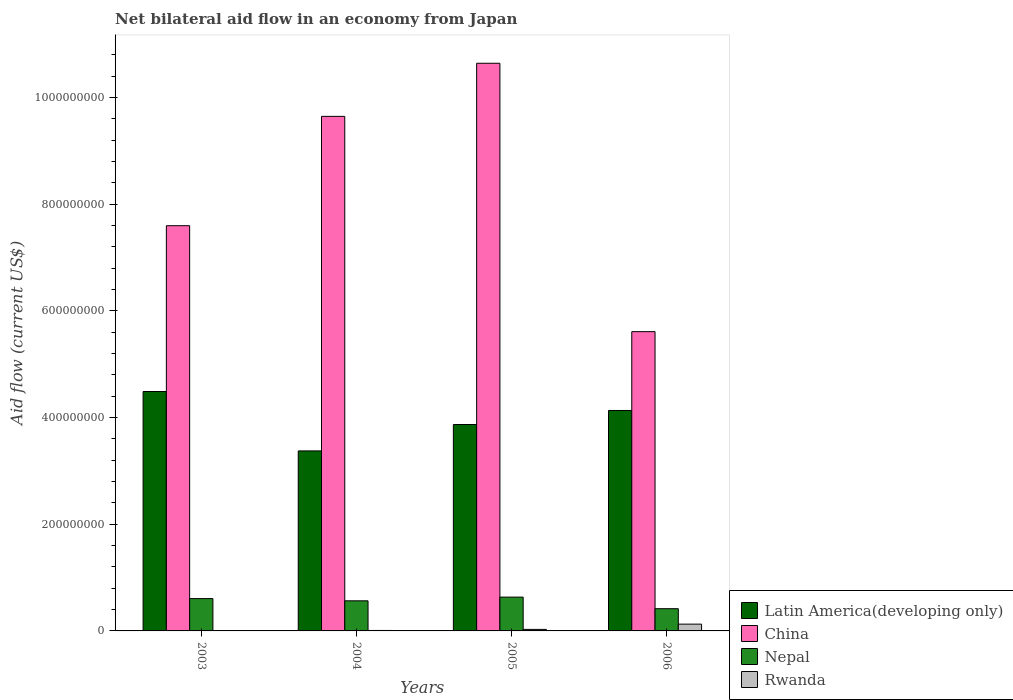How many groups of bars are there?
Your response must be concise. 4. How many bars are there on the 1st tick from the left?
Your response must be concise. 4. How many bars are there on the 2nd tick from the right?
Your answer should be very brief. 4. What is the net bilateral aid flow in Rwanda in 2003?
Make the answer very short. 6.60e+05. Across all years, what is the maximum net bilateral aid flow in Rwanda?
Your answer should be compact. 1.27e+07. Across all years, what is the minimum net bilateral aid flow in China?
Your answer should be compact. 5.61e+08. In which year was the net bilateral aid flow in Rwanda maximum?
Make the answer very short. 2006. What is the total net bilateral aid flow in Rwanda in the graph?
Provide a short and direct response. 1.71e+07. What is the difference between the net bilateral aid flow in Rwanda in 2003 and that in 2004?
Your answer should be compact. -2.00e+05. What is the difference between the net bilateral aid flow in Rwanda in 2003 and the net bilateral aid flow in China in 2004?
Offer a terse response. -9.64e+08. What is the average net bilateral aid flow in Rwanda per year?
Offer a terse response. 4.28e+06. In the year 2003, what is the difference between the net bilateral aid flow in Rwanda and net bilateral aid flow in China?
Ensure brevity in your answer.  -7.59e+08. What is the ratio of the net bilateral aid flow in Nepal in 2003 to that in 2005?
Ensure brevity in your answer.  0.96. What is the difference between the highest and the second highest net bilateral aid flow in Rwanda?
Make the answer very short. 9.89e+06. What is the difference between the highest and the lowest net bilateral aid flow in Latin America(developing only)?
Give a very brief answer. 1.11e+08. What does the 1st bar from the left in 2005 represents?
Provide a succinct answer. Latin America(developing only). Is it the case that in every year, the sum of the net bilateral aid flow in Latin America(developing only) and net bilateral aid flow in Rwanda is greater than the net bilateral aid flow in Nepal?
Offer a very short reply. Yes. How many bars are there?
Provide a short and direct response. 16. What is the difference between two consecutive major ticks on the Y-axis?
Your answer should be compact. 2.00e+08. Are the values on the major ticks of Y-axis written in scientific E-notation?
Offer a very short reply. No. Where does the legend appear in the graph?
Offer a very short reply. Bottom right. How are the legend labels stacked?
Ensure brevity in your answer.  Vertical. What is the title of the graph?
Give a very brief answer. Net bilateral aid flow in an economy from Japan. What is the label or title of the Y-axis?
Give a very brief answer. Aid flow (current US$). What is the Aid flow (current US$) in Latin America(developing only) in 2003?
Offer a terse response. 4.49e+08. What is the Aid flow (current US$) in China in 2003?
Ensure brevity in your answer.  7.60e+08. What is the Aid flow (current US$) in Nepal in 2003?
Ensure brevity in your answer.  6.06e+07. What is the Aid flow (current US$) of Latin America(developing only) in 2004?
Your answer should be compact. 3.37e+08. What is the Aid flow (current US$) in China in 2004?
Keep it short and to the point. 9.65e+08. What is the Aid flow (current US$) in Nepal in 2004?
Provide a short and direct response. 5.64e+07. What is the Aid flow (current US$) in Rwanda in 2004?
Offer a very short reply. 8.60e+05. What is the Aid flow (current US$) of Latin America(developing only) in 2005?
Give a very brief answer. 3.87e+08. What is the Aid flow (current US$) in China in 2005?
Offer a terse response. 1.06e+09. What is the Aid flow (current US$) of Nepal in 2005?
Provide a succinct answer. 6.34e+07. What is the Aid flow (current US$) of Rwanda in 2005?
Offer a terse response. 2.85e+06. What is the Aid flow (current US$) in Latin America(developing only) in 2006?
Offer a very short reply. 4.13e+08. What is the Aid flow (current US$) of China in 2006?
Offer a very short reply. 5.61e+08. What is the Aid flow (current US$) in Nepal in 2006?
Provide a short and direct response. 4.17e+07. What is the Aid flow (current US$) of Rwanda in 2006?
Your answer should be very brief. 1.27e+07. Across all years, what is the maximum Aid flow (current US$) in Latin America(developing only)?
Your answer should be very brief. 4.49e+08. Across all years, what is the maximum Aid flow (current US$) of China?
Provide a succinct answer. 1.06e+09. Across all years, what is the maximum Aid flow (current US$) of Nepal?
Provide a short and direct response. 6.34e+07. Across all years, what is the maximum Aid flow (current US$) in Rwanda?
Your response must be concise. 1.27e+07. Across all years, what is the minimum Aid flow (current US$) in Latin America(developing only)?
Make the answer very short. 3.37e+08. Across all years, what is the minimum Aid flow (current US$) in China?
Make the answer very short. 5.61e+08. Across all years, what is the minimum Aid flow (current US$) of Nepal?
Provide a short and direct response. 4.17e+07. What is the total Aid flow (current US$) of Latin America(developing only) in the graph?
Offer a very short reply. 1.59e+09. What is the total Aid flow (current US$) in China in the graph?
Provide a short and direct response. 3.35e+09. What is the total Aid flow (current US$) of Nepal in the graph?
Provide a short and direct response. 2.22e+08. What is the total Aid flow (current US$) of Rwanda in the graph?
Give a very brief answer. 1.71e+07. What is the difference between the Aid flow (current US$) of Latin America(developing only) in 2003 and that in 2004?
Provide a succinct answer. 1.11e+08. What is the difference between the Aid flow (current US$) in China in 2003 and that in 2004?
Your answer should be compact. -2.05e+08. What is the difference between the Aid flow (current US$) of Nepal in 2003 and that in 2004?
Your answer should be compact. 4.18e+06. What is the difference between the Aid flow (current US$) of Latin America(developing only) in 2003 and that in 2005?
Your answer should be compact. 6.19e+07. What is the difference between the Aid flow (current US$) of China in 2003 and that in 2005?
Provide a succinct answer. -3.05e+08. What is the difference between the Aid flow (current US$) in Nepal in 2003 and that in 2005?
Make the answer very short. -2.77e+06. What is the difference between the Aid flow (current US$) in Rwanda in 2003 and that in 2005?
Your answer should be compact. -2.19e+06. What is the difference between the Aid flow (current US$) in Latin America(developing only) in 2003 and that in 2006?
Provide a short and direct response. 3.56e+07. What is the difference between the Aid flow (current US$) of China in 2003 and that in 2006?
Your answer should be very brief. 1.99e+08. What is the difference between the Aid flow (current US$) in Nepal in 2003 and that in 2006?
Your answer should be very brief. 1.90e+07. What is the difference between the Aid flow (current US$) of Rwanda in 2003 and that in 2006?
Keep it short and to the point. -1.21e+07. What is the difference between the Aid flow (current US$) of Latin America(developing only) in 2004 and that in 2005?
Your answer should be very brief. -4.95e+07. What is the difference between the Aid flow (current US$) of China in 2004 and that in 2005?
Your answer should be compact. -9.96e+07. What is the difference between the Aid flow (current US$) in Nepal in 2004 and that in 2005?
Provide a short and direct response. -6.95e+06. What is the difference between the Aid flow (current US$) of Rwanda in 2004 and that in 2005?
Make the answer very short. -1.99e+06. What is the difference between the Aid flow (current US$) in Latin America(developing only) in 2004 and that in 2006?
Keep it short and to the point. -7.58e+07. What is the difference between the Aid flow (current US$) of China in 2004 and that in 2006?
Give a very brief answer. 4.04e+08. What is the difference between the Aid flow (current US$) in Nepal in 2004 and that in 2006?
Your answer should be compact. 1.48e+07. What is the difference between the Aid flow (current US$) in Rwanda in 2004 and that in 2006?
Make the answer very short. -1.19e+07. What is the difference between the Aid flow (current US$) of Latin America(developing only) in 2005 and that in 2006?
Your answer should be compact. -2.63e+07. What is the difference between the Aid flow (current US$) of China in 2005 and that in 2006?
Offer a terse response. 5.03e+08. What is the difference between the Aid flow (current US$) in Nepal in 2005 and that in 2006?
Offer a very short reply. 2.17e+07. What is the difference between the Aid flow (current US$) in Rwanda in 2005 and that in 2006?
Ensure brevity in your answer.  -9.89e+06. What is the difference between the Aid flow (current US$) in Latin America(developing only) in 2003 and the Aid flow (current US$) in China in 2004?
Your response must be concise. -5.16e+08. What is the difference between the Aid flow (current US$) of Latin America(developing only) in 2003 and the Aid flow (current US$) of Nepal in 2004?
Offer a very short reply. 3.92e+08. What is the difference between the Aid flow (current US$) in Latin America(developing only) in 2003 and the Aid flow (current US$) in Rwanda in 2004?
Offer a very short reply. 4.48e+08. What is the difference between the Aid flow (current US$) of China in 2003 and the Aid flow (current US$) of Nepal in 2004?
Provide a short and direct response. 7.03e+08. What is the difference between the Aid flow (current US$) of China in 2003 and the Aid flow (current US$) of Rwanda in 2004?
Your answer should be very brief. 7.59e+08. What is the difference between the Aid flow (current US$) of Nepal in 2003 and the Aid flow (current US$) of Rwanda in 2004?
Keep it short and to the point. 5.98e+07. What is the difference between the Aid flow (current US$) of Latin America(developing only) in 2003 and the Aid flow (current US$) of China in 2005?
Provide a succinct answer. -6.15e+08. What is the difference between the Aid flow (current US$) in Latin America(developing only) in 2003 and the Aid flow (current US$) in Nepal in 2005?
Keep it short and to the point. 3.85e+08. What is the difference between the Aid flow (current US$) of Latin America(developing only) in 2003 and the Aid flow (current US$) of Rwanda in 2005?
Give a very brief answer. 4.46e+08. What is the difference between the Aid flow (current US$) of China in 2003 and the Aid flow (current US$) of Nepal in 2005?
Offer a terse response. 6.96e+08. What is the difference between the Aid flow (current US$) in China in 2003 and the Aid flow (current US$) in Rwanda in 2005?
Offer a terse response. 7.57e+08. What is the difference between the Aid flow (current US$) of Nepal in 2003 and the Aid flow (current US$) of Rwanda in 2005?
Ensure brevity in your answer.  5.78e+07. What is the difference between the Aid flow (current US$) of Latin America(developing only) in 2003 and the Aid flow (current US$) of China in 2006?
Offer a very short reply. -1.12e+08. What is the difference between the Aid flow (current US$) in Latin America(developing only) in 2003 and the Aid flow (current US$) in Nepal in 2006?
Keep it short and to the point. 4.07e+08. What is the difference between the Aid flow (current US$) in Latin America(developing only) in 2003 and the Aid flow (current US$) in Rwanda in 2006?
Your answer should be compact. 4.36e+08. What is the difference between the Aid flow (current US$) in China in 2003 and the Aid flow (current US$) in Nepal in 2006?
Ensure brevity in your answer.  7.18e+08. What is the difference between the Aid flow (current US$) in China in 2003 and the Aid flow (current US$) in Rwanda in 2006?
Ensure brevity in your answer.  7.47e+08. What is the difference between the Aid flow (current US$) in Nepal in 2003 and the Aid flow (current US$) in Rwanda in 2006?
Make the answer very short. 4.79e+07. What is the difference between the Aid flow (current US$) in Latin America(developing only) in 2004 and the Aid flow (current US$) in China in 2005?
Give a very brief answer. -7.27e+08. What is the difference between the Aid flow (current US$) in Latin America(developing only) in 2004 and the Aid flow (current US$) in Nepal in 2005?
Ensure brevity in your answer.  2.74e+08. What is the difference between the Aid flow (current US$) of Latin America(developing only) in 2004 and the Aid flow (current US$) of Rwanda in 2005?
Your answer should be compact. 3.35e+08. What is the difference between the Aid flow (current US$) in China in 2004 and the Aid flow (current US$) in Nepal in 2005?
Provide a succinct answer. 9.01e+08. What is the difference between the Aid flow (current US$) of China in 2004 and the Aid flow (current US$) of Rwanda in 2005?
Provide a succinct answer. 9.62e+08. What is the difference between the Aid flow (current US$) in Nepal in 2004 and the Aid flow (current US$) in Rwanda in 2005?
Offer a terse response. 5.36e+07. What is the difference between the Aid flow (current US$) in Latin America(developing only) in 2004 and the Aid flow (current US$) in China in 2006?
Your answer should be very brief. -2.24e+08. What is the difference between the Aid flow (current US$) of Latin America(developing only) in 2004 and the Aid flow (current US$) of Nepal in 2006?
Offer a very short reply. 2.96e+08. What is the difference between the Aid flow (current US$) in Latin America(developing only) in 2004 and the Aid flow (current US$) in Rwanda in 2006?
Offer a terse response. 3.25e+08. What is the difference between the Aid flow (current US$) in China in 2004 and the Aid flow (current US$) in Nepal in 2006?
Offer a terse response. 9.23e+08. What is the difference between the Aid flow (current US$) of China in 2004 and the Aid flow (current US$) of Rwanda in 2006?
Ensure brevity in your answer.  9.52e+08. What is the difference between the Aid flow (current US$) in Nepal in 2004 and the Aid flow (current US$) in Rwanda in 2006?
Ensure brevity in your answer.  4.37e+07. What is the difference between the Aid flow (current US$) of Latin America(developing only) in 2005 and the Aid flow (current US$) of China in 2006?
Your answer should be very brief. -1.74e+08. What is the difference between the Aid flow (current US$) of Latin America(developing only) in 2005 and the Aid flow (current US$) of Nepal in 2006?
Ensure brevity in your answer.  3.45e+08. What is the difference between the Aid flow (current US$) of Latin America(developing only) in 2005 and the Aid flow (current US$) of Rwanda in 2006?
Provide a short and direct response. 3.74e+08. What is the difference between the Aid flow (current US$) in China in 2005 and the Aid flow (current US$) in Nepal in 2006?
Your answer should be compact. 1.02e+09. What is the difference between the Aid flow (current US$) of China in 2005 and the Aid flow (current US$) of Rwanda in 2006?
Offer a terse response. 1.05e+09. What is the difference between the Aid flow (current US$) of Nepal in 2005 and the Aid flow (current US$) of Rwanda in 2006?
Ensure brevity in your answer.  5.06e+07. What is the average Aid flow (current US$) in Latin America(developing only) per year?
Ensure brevity in your answer.  3.97e+08. What is the average Aid flow (current US$) in China per year?
Keep it short and to the point. 8.37e+08. What is the average Aid flow (current US$) in Nepal per year?
Your response must be concise. 5.55e+07. What is the average Aid flow (current US$) of Rwanda per year?
Give a very brief answer. 4.28e+06. In the year 2003, what is the difference between the Aid flow (current US$) of Latin America(developing only) and Aid flow (current US$) of China?
Your answer should be compact. -3.11e+08. In the year 2003, what is the difference between the Aid flow (current US$) in Latin America(developing only) and Aid flow (current US$) in Nepal?
Provide a succinct answer. 3.88e+08. In the year 2003, what is the difference between the Aid flow (current US$) in Latin America(developing only) and Aid flow (current US$) in Rwanda?
Ensure brevity in your answer.  4.48e+08. In the year 2003, what is the difference between the Aid flow (current US$) of China and Aid flow (current US$) of Nepal?
Make the answer very short. 6.99e+08. In the year 2003, what is the difference between the Aid flow (current US$) of China and Aid flow (current US$) of Rwanda?
Keep it short and to the point. 7.59e+08. In the year 2003, what is the difference between the Aid flow (current US$) of Nepal and Aid flow (current US$) of Rwanda?
Provide a short and direct response. 6.00e+07. In the year 2004, what is the difference between the Aid flow (current US$) in Latin America(developing only) and Aid flow (current US$) in China?
Keep it short and to the point. -6.27e+08. In the year 2004, what is the difference between the Aid flow (current US$) of Latin America(developing only) and Aid flow (current US$) of Nepal?
Ensure brevity in your answer.  2.81e+08. In the year 2004, what is the difference between the Aid flow (current US$) of Latin America(developing only) and Aid flow (current US$) of Rwanda?
Offer a very short reply. 3.37e+08. In the year 2004, what is the difference between the Aid flow (current US$) in China and Aid flow (current US$) in Nepal?
Offer a terse response. 9.08e+08. In the year 2004, what is the difference between the Aid flow (current US$) in China and Aid flow (current US$) in Rwanda?
Offer a very short reply. 9.64e+08. In the year 2004, what is the difference between the Aid flow (current US$) in Nepal and Aid flow (current US$) in Rwanda?
Offer a terse response. 5.56e+07. In the year 2005, what is the difference between the Aid flow (current US$) in Latin America(developing only) and Aid flow (current US$) in China?
Your answer should be very brief. -6.77e+08. In the year 2005, what is the difference between the Aid flow (current US$) of Latin America(developing only) and Aid flow (current US$) of Nepal?
Give a very brief answer. 3.24e+08. In the year 2005, what is the difference between the Aid flow (current US$) in Latin America(developing only) and Aid flow (current US$) in Rwanda?
Offer a terse response. 3.84e+08. In the year 2005, what is the difference between the Aid flow (current US$) in China and Aid flow (current US$) in Nepal?
Offer a terse response. 1.00e+09. In the year 2005, what is the difference between the Aid flow (current US$) of China and Aid flow (current US$) of Rwanda?
Your response must be concise. 1.06e+09. In the year 2005, what is the difference between the Aid flow (current US$) of Nepal and Aid flow (current US$) of Rwanda?
Provide a short and direct response. 6.05e+07. In the year 2006, what is the difference between the Aid flow (current US$) of Latin America(developing only) and Aid flow (current US$) of China?
Offer a very short reply. -1.48e+08. In the year 2006, what is the difference between the Aid flow (current US$) in Latin America(developing only) and Aid flow (current US$) in Nepal?
Provide a succinct answer. 3.72e+08. In the year 2006, what is the difference between the Aid flow (current US$) of Latin America(developing only) and Aid flow (current US$) of Rwanda?
Keep it short and to the point. 4.01e+08. In the year 2006, what is the difference between the Aid flow (current US$) in China and Aid flow (current US$) in Nepal?
Make the answer very short. 5.19e+08. In the year 2006, what is the difference between the Aid flow (current US$) in China and Aid flow (current US$) in Rwanda?
Offer a very short reply. 5.48e+08. In the year 2006, what is the difference between the Aid flow (current US$) of Nepal and Aid flow (current US$) of Rwanda?
Provide a short and direct response. 2.89e+07. What is the ratio of the Aid flow (current US$) of Latin America(developing only) in 2003 to that in 2004?
Offer a terse response. 1.33. What is the ratio of the Aid flow (current US$) of China in 2003 to that in 2004?
Give a very brief answer. 0.79. What is the ratio of the Aid flow (current US$) in Nepal in 2003 to that in 2004?
Keep it short and to the point. 1.07. What is the ratio of the Aid flow (current US$) in Rwanda in 2003 to that in 2004?
Your response must be concise. 0.77. What is the ratio of the Aid flow (current US$) of Latin America(developing only) in 2003 to that in 2005?
Make the answer very short. 1.16. What is the ratio of the Aid flow (current US$) in China in 2003 to that in 2005?
Offer a terse response. 0.71. What is the ratio of the Aid flow (current US$) in Nepal in 2003 to that in 2005?
Provide a succinct answer. 0.96. What is the ratio of the Aid flow (current US$) of Rwanda in 2003 to that in 2005?
Your response must be concise. 0.23. What is the ratio of the Aid flow (current US$) of Latin America(developing only) in 2003 to that in 2006?
Offer a terse response. 1.09. What is the ratio of the Aid flow (current US$) in China in 2003 to that in 2006?
Provide a succinct answer. 1.35. What is the ratio of the Aid flow (current US$) of Nepal in 2003 to that in 2006?
Keep it short and to the point. 1.45. What is the ratio of the Aid flow (current US$) of Rwanda in 2003 to that in 2006?
Provide a short and direct response. 0.05. What is the ratio of the Aid flow (current US$) in Latin America(developing only) in 2004 to that in 2005?
Your response must be concise. 0.87. What is the ratio of the Aid flow (current US$) of China in 2004 to that in 2005?
Keep it short and to the point. 0.91. What is the ratio of the Aid flow (current US$) in Nepal in 2004 to that in 2005?
Make the answer very short. 0.89. What is the ratio of the Aid flow (current US$) of Rwanda in 2004 to that in 2005?
Your answer should be very brief. 0.3. What is the ratio of the Aid flow (current US$) of Latin America(developing only) in 2004 to that in 2006?
Provide a succinct answer. 0.82. What is the ratio of the Aid flow (current US$) of China in 2004 to that in 2006?
Offer a very short reply. 1.72. What is the ratio of the Aid flow (current US$) of Nepal in 2004 to that in 2006?
Keep it short and to the point. 1.35. What is the ratio of the Aid flow (current US$) of Rwanda in 2004 to that in 2006?
Ensure brevity in your answer.  0.07. What is the ratio of the Aid flow (current US$) in Latin America(developing only) in 2005 to that in 2006?
Provide a succinct answer. 0.94. What is the ratio of the Aid flow (current US$) of China in 2005 to that in 2006?
Keep it short and to the point. 1.9. What is the ratio of the Aid flow (current US$) in Nepal in 2005 to that in 2006?
Keep it short and to the point. 1.52. What is the ratio of the Aid flow (current US$) in Rwanda in 2005 to that in 2006?
Your answer should be very brief. 0.22. What is the difference between the highest and the second highest Aid flow (current US$) in Latin America(developing only)?
Keep it short and to the point. 3.56e+07. What is the difference between the highest and the second highest Aid flow (current US$) in China?
Offer a very short reply. 9.96e+07. What is the difference between the highest and the second highest Aid flow (current US$) in Nepal?
Keep it short and to the point. 2.77e+06. What is the difference between the highest and the second highest Aid flow (current US$) of Rwanda?
Give a very brief answer. 9.89e+06. What is the difference between the highest and the lowest Aid flow (current US$) in Latin America(developing only)?
Provide a succinct answer. 1.11e+08. What is the difference between the highest and the lowest Aid flow (current US$) of China?
Offer a very short reply. 5.03e+08. What is the difference between the highest and the lowest Aid flow (current US$) of Nepal?
Offer a terse response. 2.17e+07. What is the difference between the highest and the lowest Aid flow (current US$) in Rwanda?
Provide a short and direct response. 1.21e+07. 